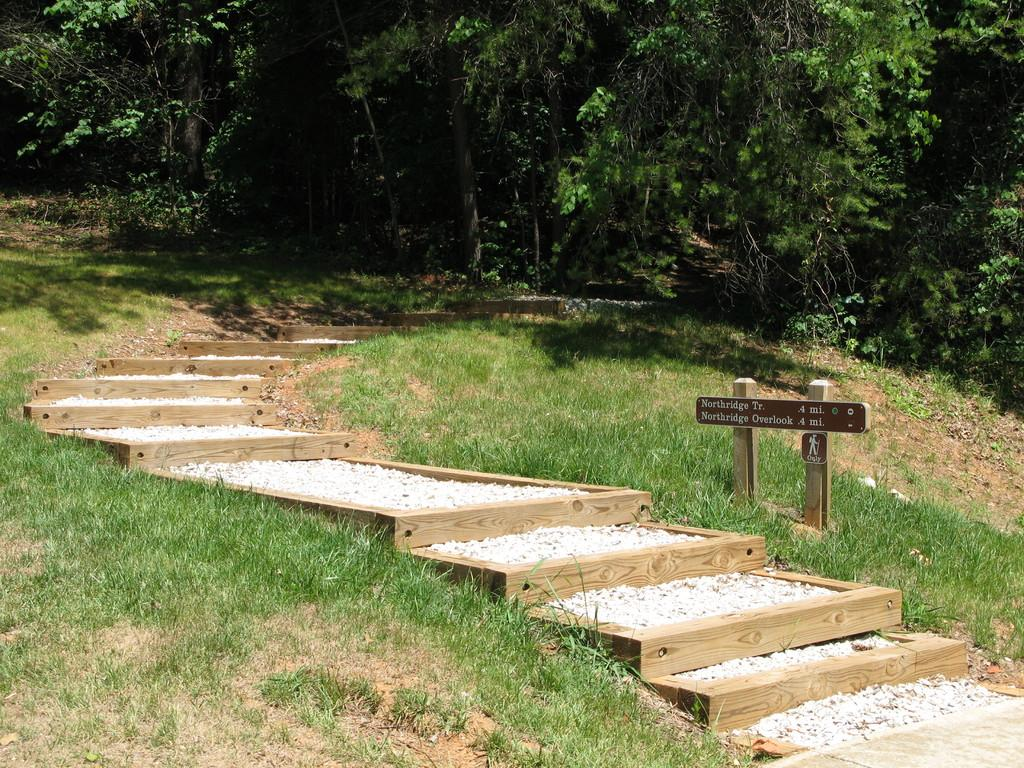What type of vegetation is present in the image? There are plants, trees, and grass in the image. What type of architectural feature can be seen in the image? There are wooden stairs in the image. What type of ground surface is visible in the image? There are stones in the image. What is the wooden board with text attached to in the image? The board is attached to two wooden poles in the image. What type of car can be seen driving on the wooden stairs in the image? There is no car present in the image, and the wooden stairs are not a road or path for vehicles. 